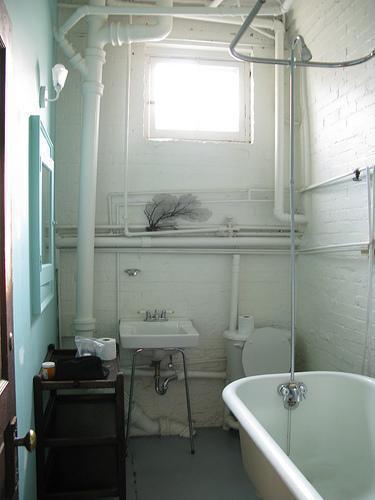How many people are in this photo?
Give a very brief answer. 0. How many windows are there?
Give a very brief answer. 1. 